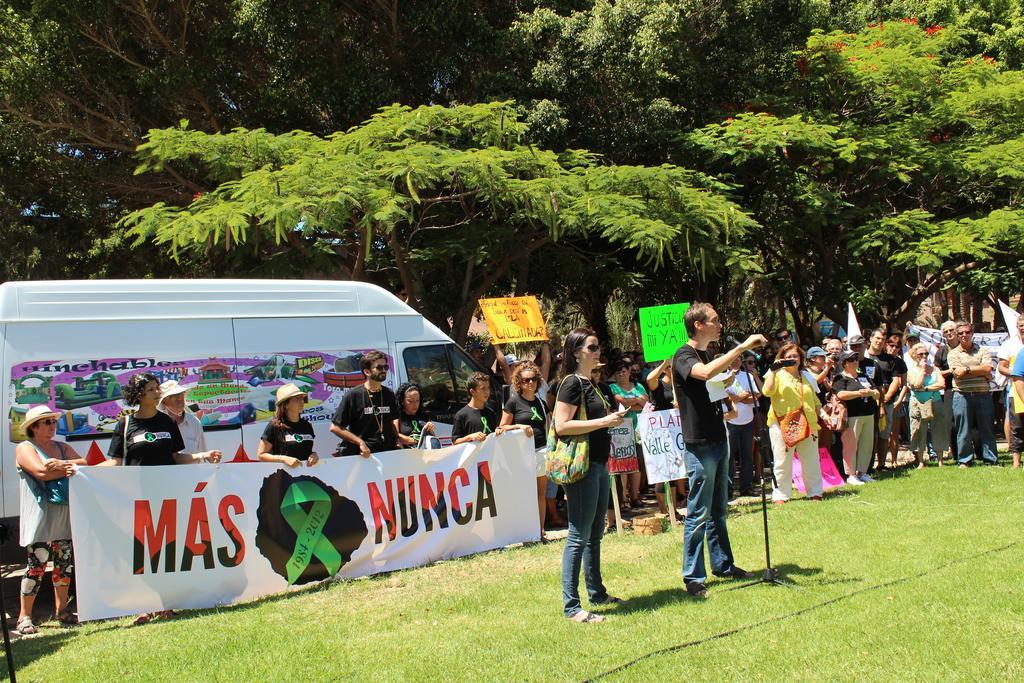Please provide a concise description of this image. In this image, we can see a man standing in front of mic and in the background, there are many people holding banners in their hands and we can see a vehicle and many trees. At the bottom, there is ground. 